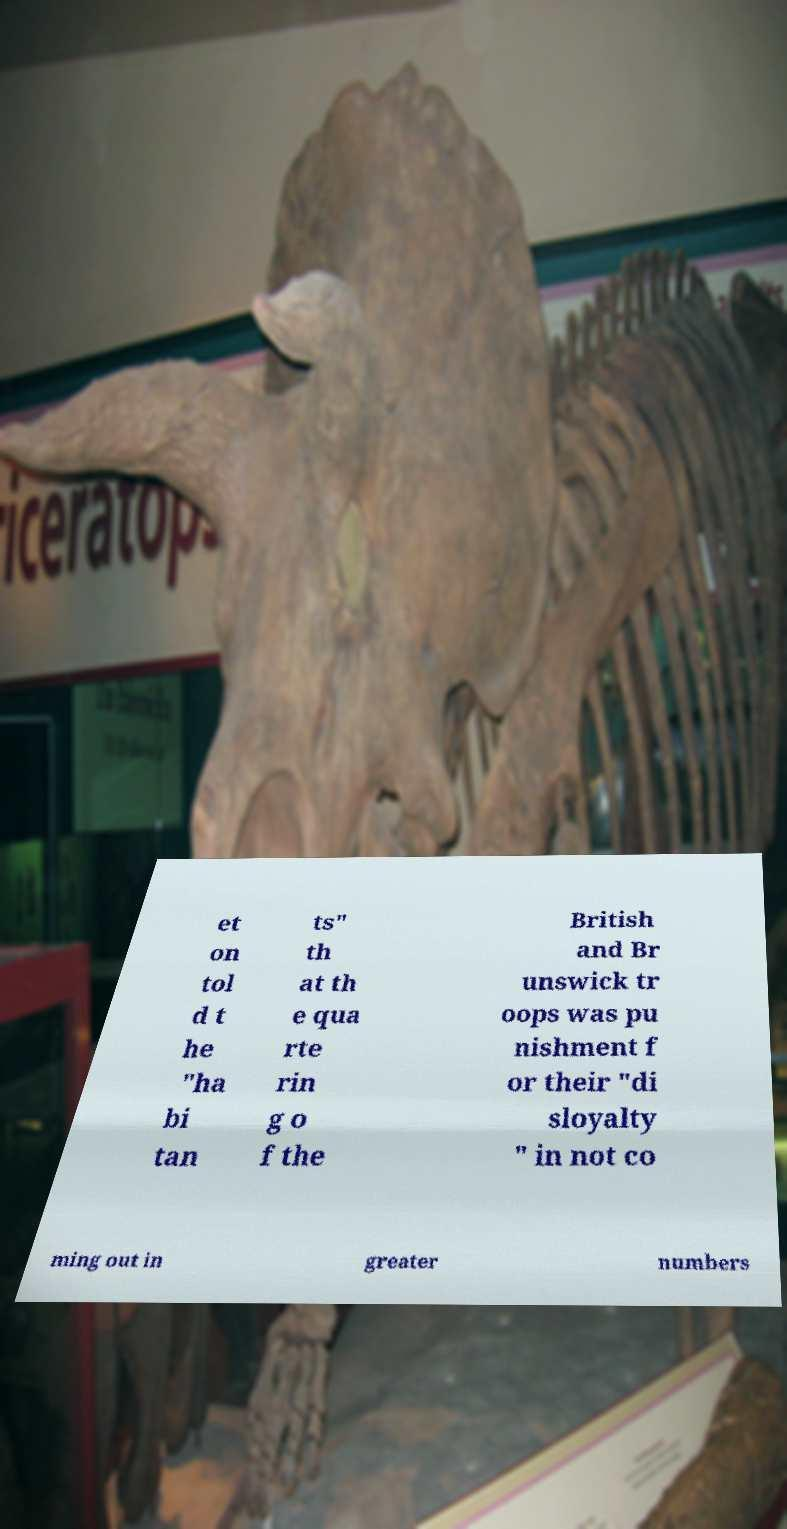There's text embedded in this image that I need extracted. Can you transcribe it verbatim? et on tol d t he "ha bi tan ts" th at th e qua rte rin g o f the British and Br unswick tr oops was pu nishment f or their "di sloyalty " in not co ming out in greater numbers 